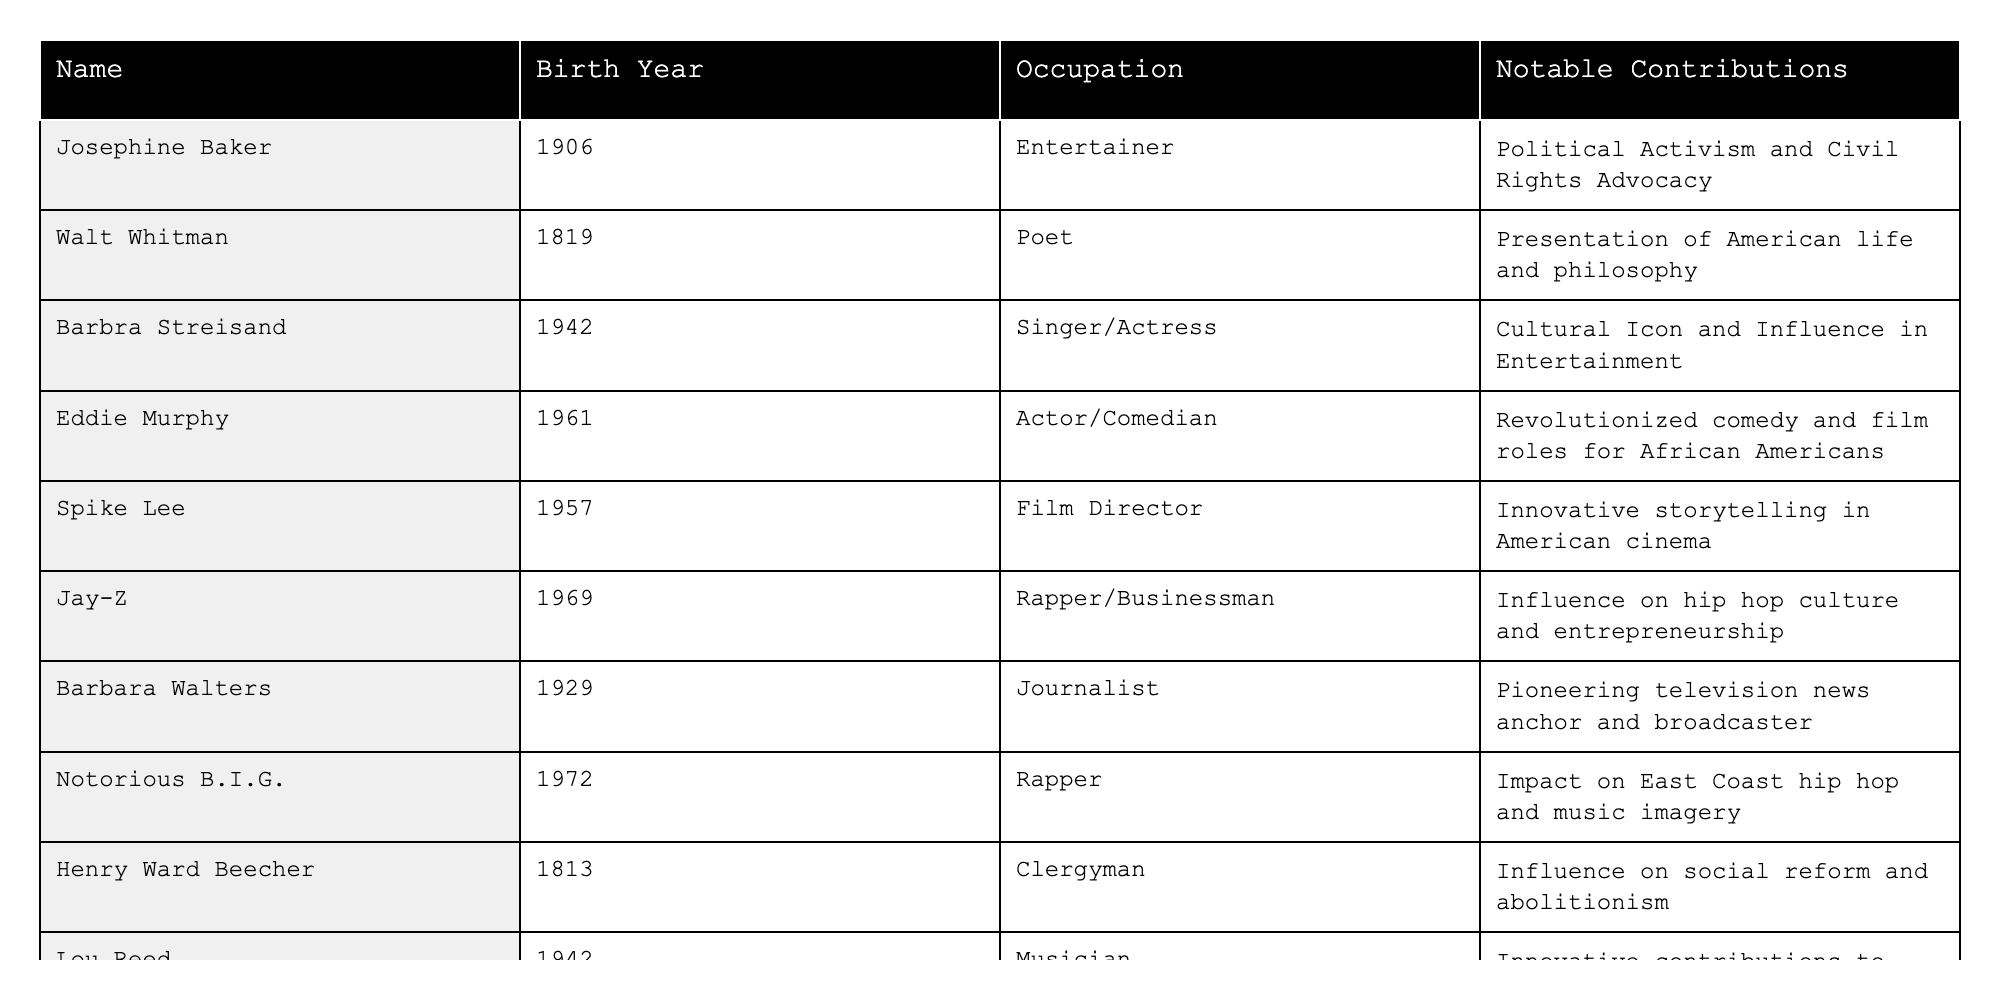What year was Josephine Baker born? Looking at the row for Josephine Baker in the table, it clearly states her birth year is 1906.
Answer: 1906 Who is the earliest born figure in the table? By scanning the birth years listed, the earliest year is 1813, which corresponds to Henry Ward Beecher.
Answer: Henry Ward Beecher What notable contribution did Barbra Streisand make? The table indicates that Barbra Streisand is known for her influence as a cultural icon in entertainment.
Answer: Cultural Icon and Influence in Entertainment How many figures in the table were born in the 1940s? Barbra Streisand (1942) and Lou Reed (1942) are the two figures born in the 1940s. Counting them gives a total of 2.
Answer: 2 Which figure is known for revolutionary contributions to African American film roles? The entry for Eddie Murphy mentions he revolutionized comedy and film roles specifically for African Americans.
Answer: Eddie Murphy Is it true that Notorious B.I.G. was the first rapper listed in the table? By checking the order of the rows, Notorious B.I.G. appears last among the rappers listed, indicating that he is not the first.
Answer: No What average birth year can be calculated from the figures listed? To find the average, sum the birth years: (1906 + 1819 + 1929 + 1942 + 1961 + 1957 + 1969 + 1972 + 1813 + 1942) = 1942.9, then divide by the number of entries (10), resulting in approximately 1943.
Answer: 1943 Which two figures share the same birth year? Looking at the table, Barbra Streisand and Lou Reed were both born in 1942, making them the only individuals with that birth year.
Answer: Barbra Streisand and Lou Reed Who among the listed figures has contributions relating to social reform? The entry for Henry Ward Beecher mentions his influence on social reform and abolitionism, giving him this notable contribution.
Answer: Henry Ward Beecher What occupation does Spike Lee hold? Referring to Spike Lee's entry in the table, he is identified as a Film Director.
Answer: Film Director 